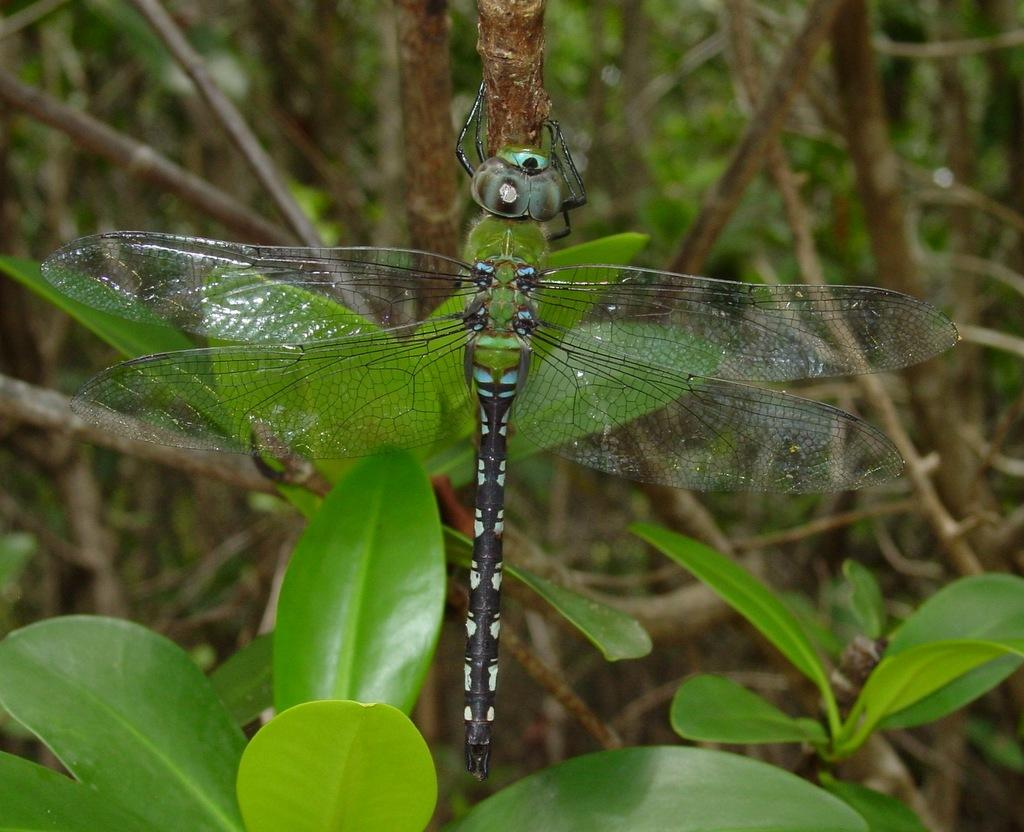What is present on the stem in the image? There is a fly on the stem in the image. What type of vegetation is at the bottom of the image? There are green leaves at the bottom of the image. What can be seen in the background of the image? There are trees and wooden sticks in the background of the image. What type of map can be seen in the image? There is no map present in the image. What is the angle of the sky in the image? The image does not depict an angle of the sky, as it is a still image. 